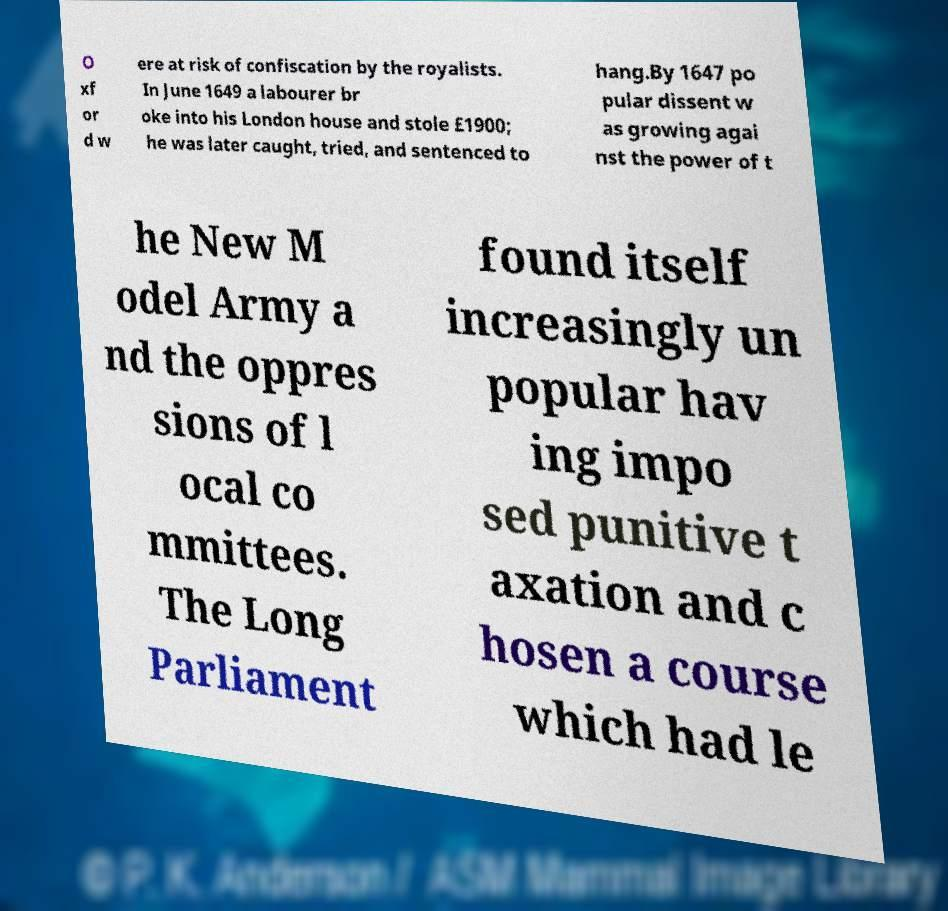Please read and relay the text visible in this image. What does it say? O xf or d w ere at risk of confiscation by the royalists. In June 1649 a labourer br oke into his London house and stole £1900; he was later caught, tried, and sentenced to hang.By 1647 po pular dissent w as growing agai nst the power of t he New M odel Army a nd the oppres sions of l ocal co mmittees. The Long Parliament found itself increasingly un popular hav ing impo sed punitive t axation and c hosen a course which had le 